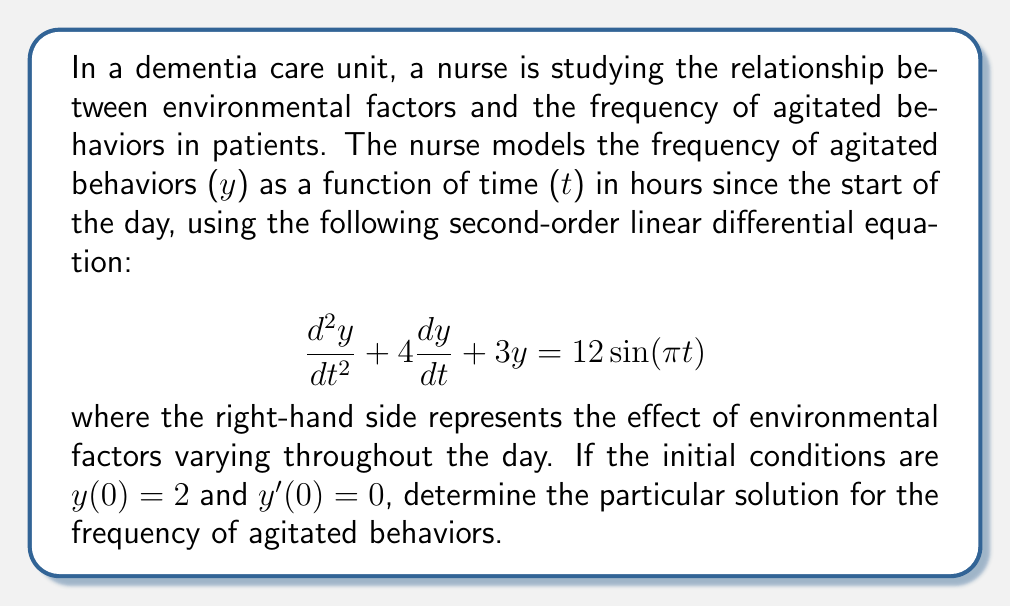Show me your answer to this math problem. To solve this second-order linear differential equation, we'll follow these steps:

1) First, we need to find the complementary solution $y_c(t)$. The characteristic equation is:
   $$r^2 + 4r + 3 = 0$$
   Solving this, we get $r_1 = -1$ and $r_2 = -3$. So, the complementary solution is:
   $$y_c(t) = c_1e^{-t} + c_2e^{-3t}$$

2) Next, we need to find the particular solution $y_p(t)$. Given the right-hand side of the equation, we can assume a solution of the form:
   $$y_p(t) = A\cos(\pi t) + B\sin(\pi t)$$

3) Substituting this into the original equation:
   $$(-A\pi^2\cos(\pi t) - B\pi^2\sin(\pi t)) + 4(-A\pi\sin(\pi t) + B\pi\cos(\pi t)) + 3(A\cos(\pi t) + B\sin(\pi t)) = 12\sin(\pi t)$$

4) Equating coefficients:
   $$(3-\pi^2)A + 4\pi B = 0$$
   $$-4\pi A + (3-\pi^2)B = 12$$

5) Solving this system of equations:
   $$A = \frac{-48\pi}{(3-\pi^2)^2 + 16\pi^2}, B = \frac{12(3-\pi^2)}{(3-\pi^2)^2 + 16\pi^2}$$

6) The general solution is $y(t) = y_c(t) + y_p(t)$:
   $$y(t) = c_1e^{-t} + c_2e^{-3t} + A\cos(\pi t) + B\sin(\pi t)$$

7) Using the initial conditions:
   $y(0) = 2$ gives: $c_1 + c_2 + A = 2$
   $y'(0) = 0$ gives: $-c_1 - 3c_2 + B\pi = 0$

8) Solving these equations:
   $$c_1 = 2 - A - \frac{B\pi}{2}, c_2 = \frac{B\pi}{2}$$

Therefore, the particular solution is:
$$y(t) = (2-A-\frac{B\pi}{2})e^{-t} + \frac{B\pi}{2}e^{-3t} + A\cos(\pi t) + B\sin(\pi t)$$
where $A$ and $B$ are as calculated in step 5.
Answer: $$y(t) = (2-A-\frac{B\pi}{2})e^{-t} + \frac{B\pi}{2}e^{-3t} + A\cos(\pi t) + B\sin(\pi t)$$
where $A = \frac{-48\pi}{(3-\pi^2)^2 + 16\pi^2}$ and $B = \frac{12(3-\pi^2)}{(3-\pi^2)^2 + 16\pi^2}$ 